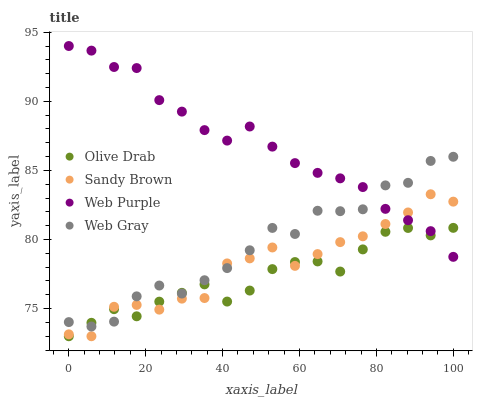Does Olive Drab have the minimum area under the curve?
Answer yes or no. Yes. Does Web Purple have the maximum area under the curve?
Answer yes or no. Yes. Does Web Gray have the minimum area under the curve?
Answer yes or no. No. Does Web Gray have the maximum area under the curve?
Answer yes or no. No. Is Web Purple the smoothest?
Answer yes or no. Yes. Is Sandy Brown the roughest?
Answer yes or no. Yes. Is Web Gray the smoothest?
Answer yes or no. No. Is Web Gray the roughest?
Answer yes or no. No. Does Sandy Brown have the lowest value?
Answer yes or no. Yes. Does Web Gray have the lowest value?
Answer yes or no. No. Does Web Purple have the highest value?
Answer yes or no. Yes. Does Web Gray have the highest value?
Answer yes or no. No. Does Sandy Brown intersect Web Gray?
Answer yes or no. Yes. Is Sandy Brown less than Web Gray?
Answer yes or no. No. Is Sandy Brown greater than Web Gray?
Answer yes or no. No. 